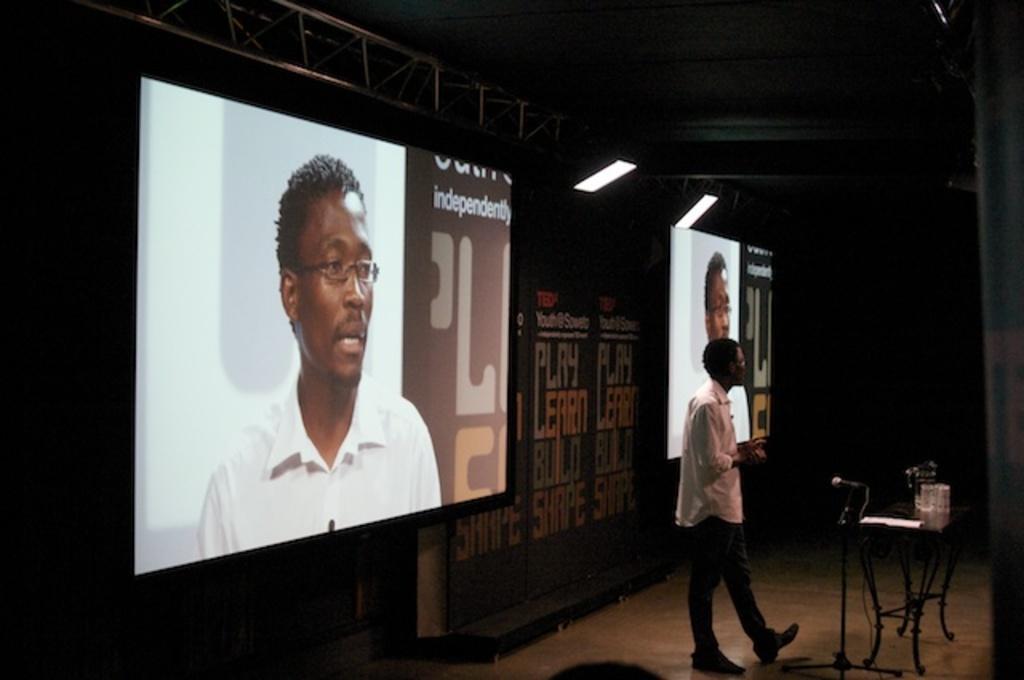Please provide a concise description of this image. There is a person standing. Near to him there is a table and a mic with mic stand. On the table there are many items. In the back there is a wall with something written on that. Also there are screens. On the screen we can see a person wearing a specs. On the top there are lights with stand. 